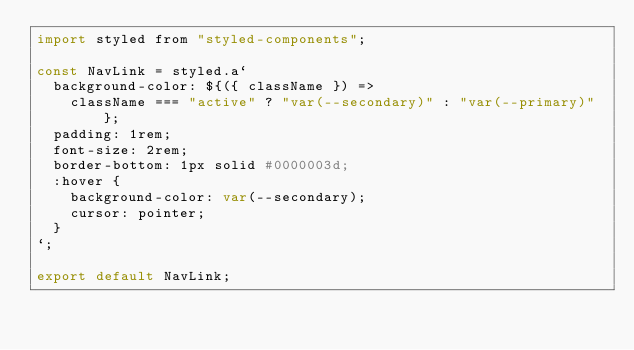Convert code to text. <code><loc_0><loc_0><loc_500><loc_500><_JavaScript_>import styled from "styled-components";

const NavLink = styled.a`
  background-color: ${({ className }) =>
    className === "active" ? "var(--secondary)" : "var(--primary)"};
  padding: 1rem;
  font-size: 2rem;
  border-bottom: 1px solid #0000003d;
  :hover {
    background-color: var(--secondary);
    cursor: pointer;
  }
`;

export default NavLink;
</code> 